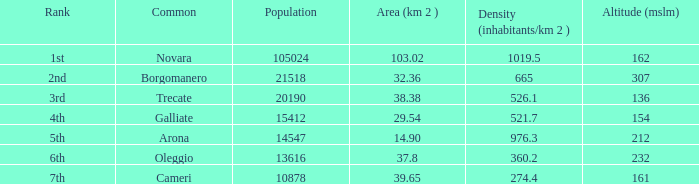Which common has an area (km2) of 103.02? Novara. 